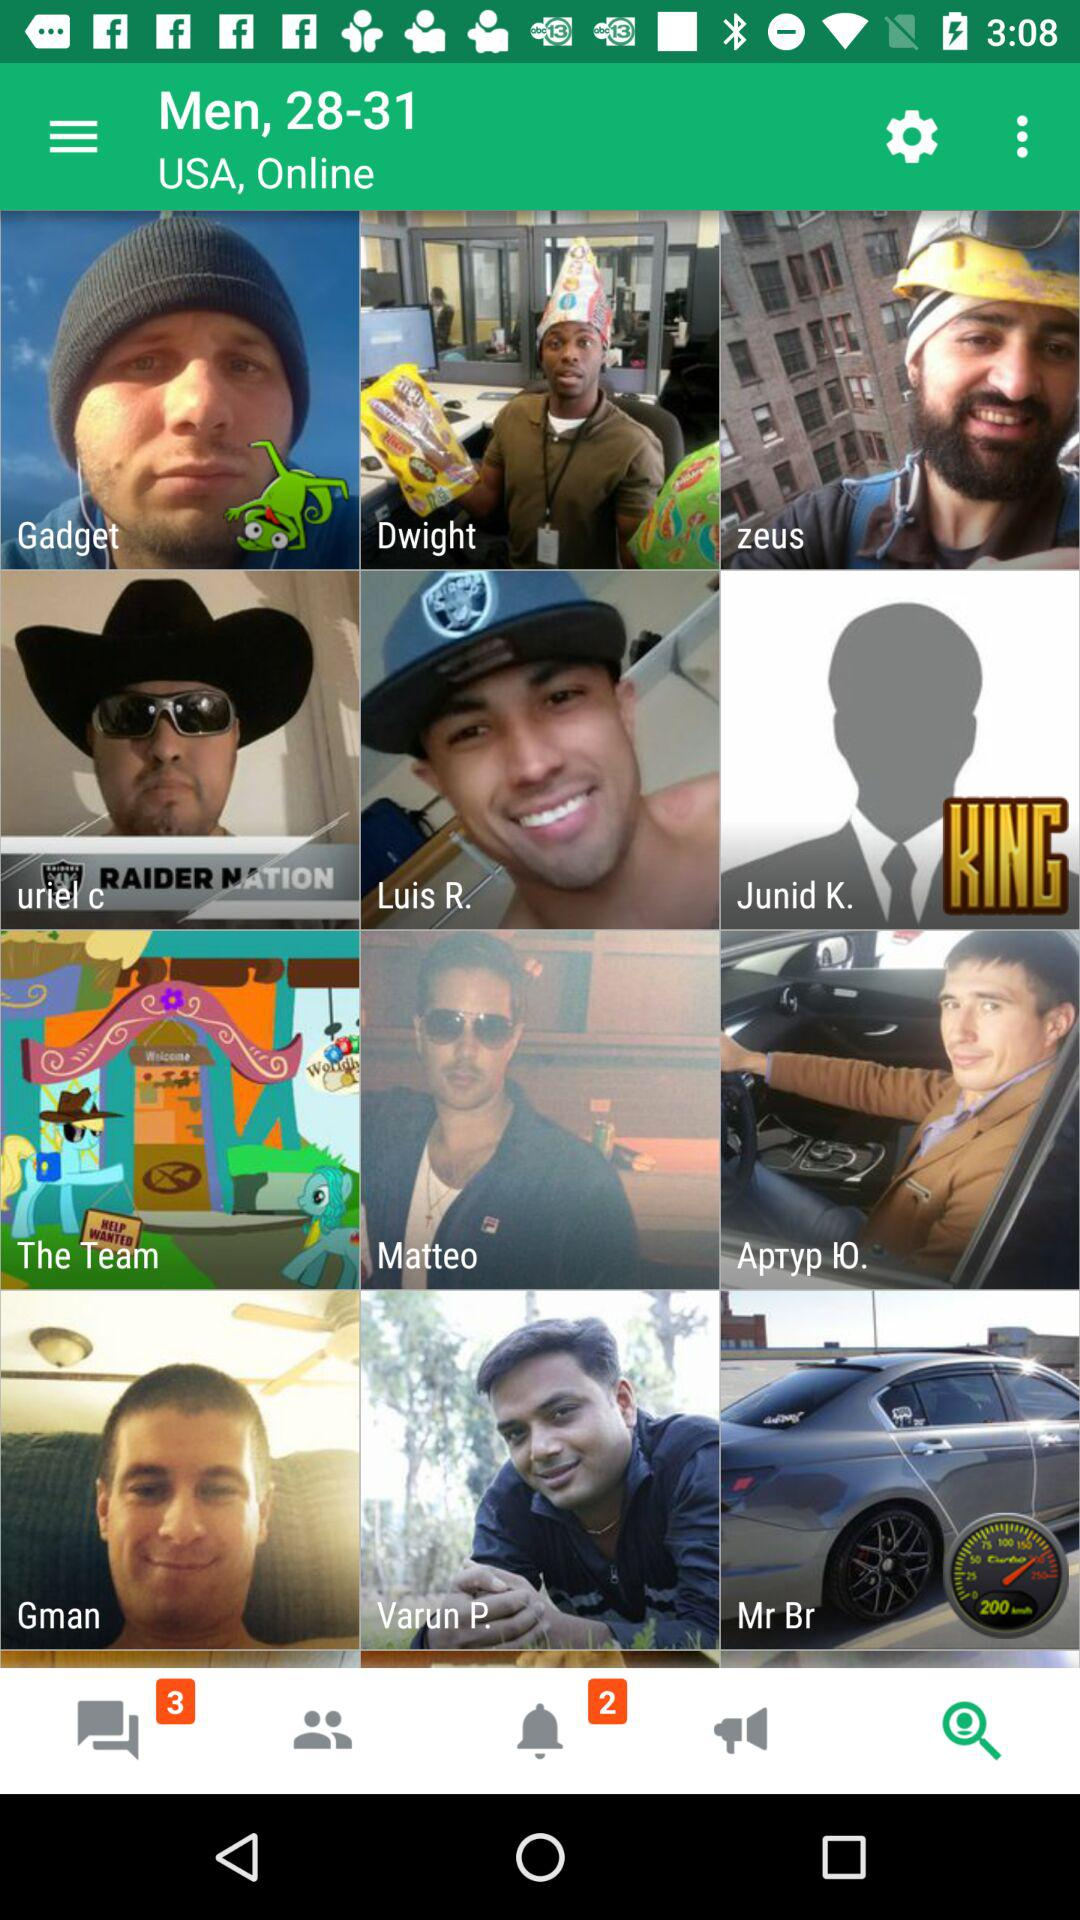Are there any unread messages?
When the provided information is insufficient, respond with <no answer>. <no answer> 